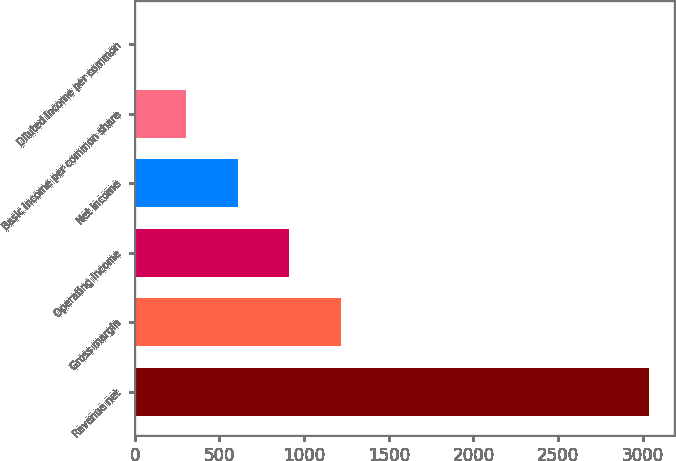Convert chart to OTSL. <chart><loc_0><loc_0><loc_500><loc_500><bar_chart><fcel>Revenue net<fcel>Gross margin<fcel>Operating income<fcel>Net income<fcel>Basic income per common share<fcel>Diluted income per common<nl><fcel>3035<fcel>1215.16<fcel>911.86<fcel>608.56<fcel>305.26<fcel>1.96<nl></chart> 